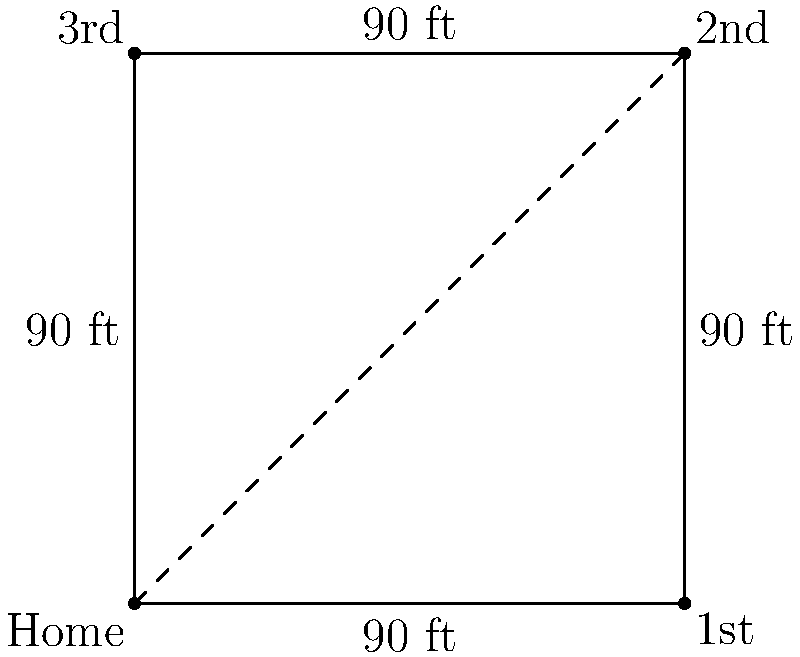As a Valdosta State baseball enthusiast, you're analyzing the dimensions of a regulation baseball diamond. If the distance between each base is 90 feet, what is the total area of the diamond in square feet? Let's approach this step-by-step:

1) A baseball diamond is actually a square when viewed from above.

2) We're given that the distance between each base is 90 feet. This means each side of the square is 90 feet long.

3) To calculate the area of a square, we use the formula:

   $$A = s^2$$

   Where $A$ is the area and $s$ is the length of a side.

4) Plugging in our value:

   $$A = 90^2 = 90 \times 90 = 8,100$$

5) Therefore, the area of the baseball diamond is 8,100 square feet.

This calculation doesn't include the infield grass or the area beyond the baselines, just the square formed by the bases themselves.
Answer: 8,100 square feet 